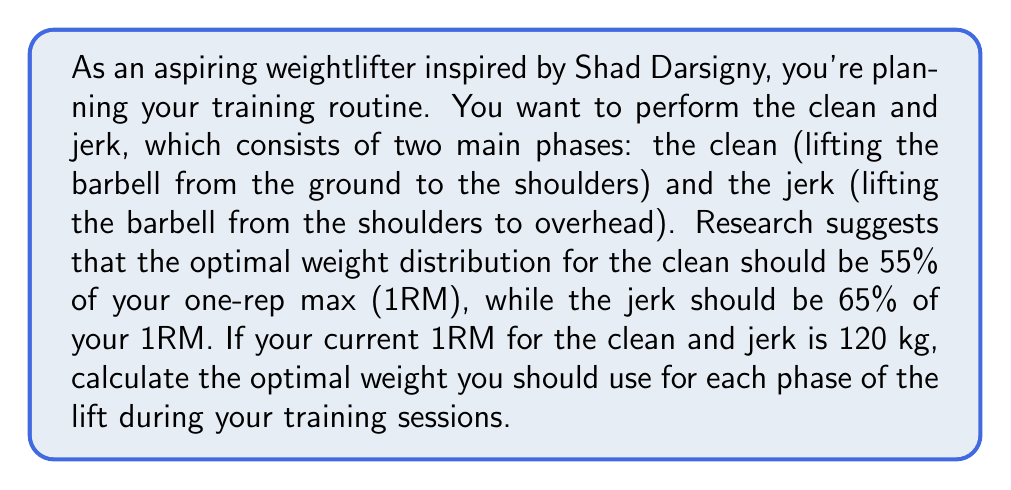Show me your answer to this math problem. To solve this problem, we need to follow these steps:

1. Identify the given information:
   - Clean weight should be 55% of 1RM
   - Jerk weight should be 65% of 1RM
   - Current 1RM for clean and jerk is 120 kg

2. Calculate the optimal weight for the clean:
   Let $W_c$ be the weight for the clean.
   $$W_c = 0.55 \times 1RM$$
   $$W_c = 0.55 \times 120 \text{ kg}$$
   $$W_c = 66 \text{ kg}$$

3. Calculate the optimal weight for the jerk:
   Let $W_j$ be the weight for the jerk.
   $$W_j = 0.65 \times 1RM$$
   $$W_j = 0.65 \times 120 \text{ kg}$$
   $$W_j = 78 \text{ kg}$$

4. Round the weights to the nearest whole number, as fractional plates are not commonly used in weightlifting.
Answer: The optimal weight for the clean is 66 kg, and the optimal weight for the jerk is 78 kg. 